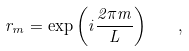Convert formula to latex. <formula><loc_0><loc_0><loc_500><loc_500>r _ { m } = \exp \left ( i \frac { 2 \pi m } { L } \right ) \quad ,</formula> 